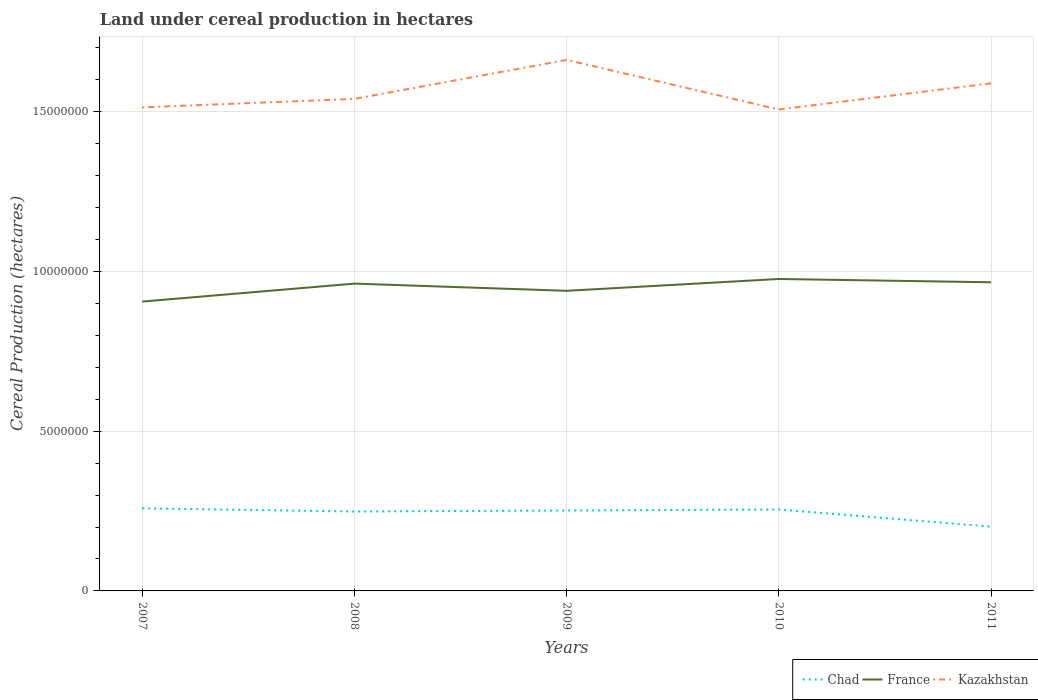Does the line corresponding to Kazakhstan intersect with the line corresponding to Chad?
Make the answer very short. No. Is the number of lines equal to the number of legend labels?
Your response must be concise. Yes. Across all years, what is the maximum land under cereal production in Chad?
Provide a short and direct response. 2.01e+06. What is the total land under cereal production in Chad in the graph?
Give a very brief answer. 9.73e+04. What is the difference between the highest and the second highest land under cereal production in Kazakhstan?
Offer a terse response. 1.55e+06. What is the difference between the highest and the lowest land under cereal production in Chad?
Give a very brief answer. 4. Is the land under cereal production in Kazakhstan strictly greater than the land under cereal production in Chad over the years?
Ensure brevity in your answer.  No. Are the values on the major ticks of Y-axis written in scientific E-notation?
Provide a succinct answer. No. Does the graph contain any zero values?
Give a very brief answer. No. Does the graph contain grids?
Provide a short and direct response. Yes. Where does the legend appear in the graph?
Make the answer very short. Bottom right. What is the title of the graph?
Your answer should be compact. Land under cereal production in hectares. Does "Euro area" appear as one of the legend labels in the graph?
Make the answer very short. No. What is the label or title of the Y-axis?
Your answer should be compact. Cereal Production (hectares). What is the Cereal Production (hectares) in Chad in 2007?
Keep it short and to the point. 2.58e+06. What is the Cereal Production (hectares) in France in 2007?
Offer a terse response. 9.06e+06. What is the Cereal Production (hectares) of Kazakhstan in 2007?
Your answer should be compact. 1.51e+07. What is the Cereal Production (hectares) in Chad in 2008?
Give a very brief answer. 2.49e+06. What is the Cereal Production (hectares) of France in 2008?
Offer a terse response. 9.62e+06. What is the Cereal Production (hectares) of Kazakhstan in 2008?
Provide a succinct answer. 1.54e+07. What is the Cereal Production (hectares) in Chad in 2009?
Your answer should be compact. 2.52e+06. What is the Cereal Production (hectares) in France in 2009?
Your answer should be very brief. 9.39e+06. What is the Cereal Production (hectares) of Kazakhstan in 2009?
Provide a succinct answer. 1.66e+07. What is the Cereal Production (hectares) in Chad in 2010?
Ensure brevity in your answer.  2.55e+06. What is the Cereal Production (hectares) of France in 2010?
Keep it short and to the point. 9.76e+06. What is the Cereal Production (hectares) of Kazakhstan in 2010?
Provide a succinct answer. 1.51e+07. What is the Cereal Production (hectares) of Chad in 2011?
Your response must be concise. 2.01e+06. What is the Cereal Production (hectares) in France in 2011?
Make the answer very short. 9.66e+06. What is the Cereal Production (hectares) of Kazakhstan in 2011?
Ensure brevity in your answer.  1.59e+07. Across all years, what is the maximum Cereal Production (hectares) of Chad?
Offer a very short reply. 2.58e+06. Across all years, what is the maximum Cereal Production (hectares) of France?
Your answer should be very brief. 9.76e+06. Across all years, what is the maximum Cereal Production (hectares) of Kazakhstan?
Your response must be concise. 1.66e+07. Across all years, what is the minimum Cereal Production (hectares) of Chad?
Your answer should be compact. 2.01e+06. Across all years, what is the minimum Cereal Production (hectares) of France?
Your response must be concise. 9.06e+06. Across all years, what is the minimum Cereal Production (hectares) in Kazakhstan?
Offer a very short reply. 1.51e+07. What is the total Cereal Production (hectares) in Chad in the graph?
Your answer should be compact. 1.21e+07. What is the total Cereal Production (hectares) of France in the graph?
Keep it short and to the point. 4.75e+07. What is the total Cereal Production (hectares) in Kazakhstan in the graph?
Provide a succinct answer. 7.81e+07. What is the difference between the Cereal Production (hectares) of Chad in 2007 and that in 2008?
Make the answer very short. 9.73e+04. What is the difference between the Cereal Production (hectares) of France in 2007 and that in 2008?
Offer a terse response. -5.62e+05. What is the difference between the Cereal Production (hectares) in Kazakhstan in 2007 and that in 2008?
Offer a terse response. -2.65e+05. What is the difference between the Cereal Production (hectares) of Chad in 2007 and that in 2009?
Offer a very short reply. 6.77e+04. What is the difference between the Cereal Production (hectares) of France in 2007 and that in 2009?
Make the answer very short. -3.37e+05. What is the difference between the Cereal Production (hectares) in Kazakhstan in 2007 and that in 2009?
Your answer should be very brief. -1.48e+06. What is the difference between the Cereal Production (hectares) in Chad in 2007 and that in 2010?
Offer a very short reply. 3.42e+04. What is the difference between the Cereal Production (hectares) of France in 2007 and that in 2010?
Keep it short and to the point. -7.07e+05. What is the difference between the Cereal Production (hectares) of Kazakhstan in 2007 and that in 2010?
Your answer should be compact. 6.62e+04. What is the difference between the Cereal Production (hectares) in Chad in 2007 and that in 2011?
Give a very brief answer. 5.73e+05. What is the difference between the Cereal Production (hectares) of France in 2007 and that in 2011?
Provide a short and direct response. -6.04e+05. What is the difference between the Cereal Production (hectares) in Kazakhstan in 2007 and that in 2011?
Offer a very short reply. -7.51e+05. What is the difference between the Cereal Production (hectares) of Chad in 2008 and that in 2009?
Your answer should be compact. -2.96e+04. What is the difference between the Cereal Production (hectares) in France in 2008 and that in 2009?
Provide a short and direct response. 2.25e+05. What is the difference between the Cereal Production (hectares) in Kazakhstan in 2008 and that in 2009?
Provide a short and direct response. -1.22e+06. What is the difference between the Cereal Production (hectares) of Chad in 2008 and that in 2010?
Offer a very short reply. -6.31e+04. What is the difference between the Cereal Production (hectares) of France in 2008 and that in 2010?
Ensure brevity in your answer.  -1.45e+05. What is the difference between the Cereal Production (hectares) of Kazakhstan in 2008 and that in 2010?
Make the answer very short. 3.31e+05. What is the difference between the Cereal Production (hectares) in Chad in 2008 and that in 2011?
Ensure brevity in your answer.  4.76e+05. What is the difference between the Cereal Production (hectares) in France in 2008 and that in 2011?
Make the answer very short. -4.14e+04. What is the difference between the Cereal Production (hectares) of Kazakhstan in 2008 and that in 2011?
Keep it short and to the point. -4.87e+05. What is the difference between the Cereal Production (hectares) of Chad in 2009 and that in 2010?
Your answer should be very brief. -3.35e+04. What is the difference between the Cereal Production (hectares) in France in 2009 and that in 2010?
Give a very brief answer. -3.70e+05. What is the difference between the Cereal Production (hectares) in Kazakhstan in 2009 and that in 2010?
Provide a short and direct response. 1.55e+06. What is the difference between the Cereal Production (hectares) in Chad in 2009 and that in 2011?
Your response must be concise. 5.05e+05. What is the difference between the Cereal Production (hectares) in France in 2009 and that in 2011?
Give a very brief answer. -2.67e+05. What is the difference between the Cereal Production (hectares) of Kazakhstan in 2009 and that in 2011?
Give a very brief answer. 7.33e+05. What is the difference between the Cereal Production (hectares) in Chad in 2010 and that in 2011?
Keep it short and to the point. 5.39e+05. What is the difference between the Cereal Production (hectares) of France in 2010 and that in 2011?
Provide a succinct answer. 1.04e+05. What is the difference between the Cereal Production (hectares) of Kazakhstan in 2010 and that in 2011?
Make the answer very short. -8.18e+05. What is the difference between the Cereal Production (hectares) in Chad in 2007 and the Cereal Production (hectares) in France in 2008?
Provide a succinct answer. -7.03e+06. What is the difference between the Cereal Production (hectares) in Chad in 2007 and the Cereal Production (hectares) in Kazakhstan in 2008?
Ensure brevity in your answer.  -1.28e+07. What is the difference between the Cereal Production (hectares) in France in 2007 and the Cereal Production (hectares) in Kazakhstan in 2008?
Give a very brief answer. -6.34e+06. What is the difference between the Cereal Production (hectares) of Chad in 2007 and the Cereal Production (hectares) of France in 2009?
Provide a succinct answer. -6.81e+06. What is the difference between the Cereal Production (hectares) of Chad in 2007 and the Cereal Production (hectares) of Kazakhstan in 2009?
Keep it short and to the point. -1.40e+07. What is the difference between the Cereal Production (hectares) in France in 2007 and the Cereal Production (hectares) in Kazakhstan in 2009?
Offer a very short reply. -7.56e+06. What is the difference between the Cereal Production (hectares) of Chad in 2007 and the Cereal Production (hectares) of France in 2010?
Give a very brief answer. -7.18e+06. What is the difference between the Cereal Production (hectares) in Chad in 2007 and the Cereal Production (hectares) in Kazakhstan in 2010?
Your answer should be very brief. -1.25e+07. What is the difference between the Cereal Production (hectares) of France in 2007 and the Cereal Production (hectares) of Kazakhstan in 2010?
Your answer should be very brief. -6.01e+06. What is the difference between the Cereal Production (hectares) of Chad in 2007 and the Cereal Production (hectares) of France in 2011?
Keep it short and to the point. -7.08e+06. What is the difference between the Cereal Production (hectares) of Chad in 2007 and the Cereal Production (hectares) of Kazakhstan in 2011?
Your response must be concise. -1.33e+07. What is the difference between the Cereal Production (hectares) of France in 2007 and the Cereal Production (hectares) of Kazakhstan in 2011?
Provide a short and direct response. -6.83e+06. What is the difference between the Cereal Production (hectares) of Chad in 2008 and the Cereal Production (hectares) of France in 2009?
Keep it short and to the point. -6.91e+06. What is the difference between the Cereal Production (hectares) of Chad in 2008 and the Cereal Production (hectares) of Kazakhstan in 2009?
Offer a very short reply. -1.41e+07. What is the difference between the Cereal Production (hectares) of France in 2008 and the Cereal Production (hectares) of Kazakhstan in 2009?
Provide a short and direct response. -7.00e+06. What is the difference between the Cereal Production (hectares) of Chad in 2008 and the Cereal Production (hectares) of France in 2010?
Your response must be concise. -7.28e+06. What is the difference between the Cereal Production (hectares) of Chad in 2008 and the Cereal Production (hectares) of Kazakhstan in 2010?
Keep it short and to the point. -1.26e+07. What is the difference between the Cereal Production (hectares) of France in 2008 and the Cereal Production (hectares) of Kazakhstan in 2010?
Keep it short and to the point. -5.45e+06. What is the difference between the Cereal Production (hectares) in Chad in 2008 and the Cereal Production (hectares) in France in 2011?
Offer a very short reply. -7.17e+06. What is the difference between the Cereal Production (hectares) of Chad in 2008 and the Cereal Production (hectares) of Kazakhstan in 2011?
Make the answer very short. -1.34e+07. What is the difference between the Cereal Production (hectares) in France in 2008 and the Cereal Production (hectares) in Kazakhstan in 2011?
Your answer should be compact. -6.27e+06. What is the difference between the Cereal Production (hectares) in Chad in 2009 and the Cereal Production (hectares) in France in 2010?
Ensure brevity in your answer.  -7.25e+06. What is the difference between the Cereal Production (hectares) in Chad in 2009 and the Cereal Production (hectares) in Kazakhstan in 2010?
Offer a very short reply. -1.26e+07. What is the difference between the Cereal Production (hectares) in France in 2009 and the Cereal Production (hectares) in Kazakhstan in 2010?
Give a very brief answer. -5.68e+06. What is the difference between the Cereal Production (hectares) in Chad in 2009 and the Cereal Production (hectares) in France in 2011?
Your answer should be very brief. -7.14e+06. What is the difference between the Cereal Production (hectares) of Chad in 2009 and the Cereal Production (hectares) of Kazakhstan in 2011?
Keep it short and to the point. -1.34e+07. What is the difference between the Cereal Production (hectares) of France in 2009 and the Cereal Production (hectares) of Kazakhstan in 2011?
Give a very brief answer. -6.49e+06. What is the difference between the Cereal Production (hectares) in Chad in 2010 and the Cereal Production (hectares) in France in 2011?
Give a very brief answer. -7.11e+06. What is the difference between the Cereal Production (hectares) of Chad in 2010 and the Cereal Production (hectares) of Kazakhstan in 2011?
Your answer should be compact. -1.33e+07. What is the difference between the Cereal Production (hectares) of France in 2010 and the Cereal Production (hectares) of Kazakhstan in 2011?
Keep it short and to the point. -6.12e+06. What is the average Cereal Production (hectares) of Chad per year?
Keep it short and to the point. 2.43e+06. What is the average Cereal Production (hectares) in France per year?
Offer a very short reply. 9.50e+06. What is the average Cereal Production (hectares) of Kazakhstan per year?
Ensure brevity in your answer.  1.56e+07. In the year 2007, what is the difference between the Cereal Production (hectares) in Chad and Cereal Production (hectares) in France?
Ensure brevity in your answer.  -6.47e+06. In the year 2007, what is the difference between the Cereal Production (hectares) of Chad and Cereal Production (hectares) of Kazakhstan?
Provide a succinct answer. -1.26e+07. In the year 2007, what is the difference between the Cereal Production (hectares) in France and Cereal Production (hectares) in Kazakhstan?
Your response must be concise. -6.08e+06. In the year 2008, what is the difference between the Cereal Production (hectares) in Chad and Cereal Production (hectares) in France?
Your response must be concise. -7.13e+06. In the year 2008, what is the difference between the Cereal Production (hectares) of Chad and Cereal Production (hectares) of Kazakhstan?
Your answer should be compact. -1.29e+07. In the year 2008, what is the difference between the Cereal Production (hectares) of France and Cereal Production (hectares) of Kazakhstan?
Keep it short and to the point. -5.78e+06. In the year 2009, what is the difference between the Cereal Production (hectares) in Chad and Cereal Production (hectares) in France?
Your answer should be compact. -6.88e+06. In the year 2009, what is the difference between the Cereal Production (hectares) in Chad and Cereal Production (hectares) in Kazakhstan?
Provide a short and direct response. -1.41e+07. In the year 2009, what is the difference between the Cereal Production (hectares) of France and Cereal Production (hectares) of Kazakhstan?
Your answer should be very brief. -7.23e+06. In the year 2010, what is the difference between the Cereal Production (hectares) in Chad and Cereal Production (hectares) in France?
Your answer should be very brief. -7.21e+06. In the year 2010, what is the difference between the Cereal Production (hectares) of Chad and Cereal Production (hectares) of Kazakhstan?
Ensure brevity in your answer.  -1.25e+07. In the year 2010, what is the difference between the Cereal Production (hectares) of France and Cereal Production (hectares) of Kazakhstan?
Your response must be concise. -5.31e+06. In the year 2011, what is the difference between the Cereal Production (hectares) of Chad and Cereal Production (hectares) of France?
Keep it short and to the point. -7.65e+06. In the year 2011, what is the difference between the Cereal Production (hectares) of Chad and Cereal Production (hectares) of Kazakhstan?
Offer a terse response. -1.39e+07. In the year 2011, what is the difference between the Cereal Production (hectares) of France and Cereal Production (hectares) of Kazakhstan?
Provide a short and direct response. -6.23e+06. What is the ratio of the Cereal Production (hectares) of Chad in 2007 to that in 2008?
Provide a short and direct response. 1.04. What is the ratio of the Cereal Production (hectares) in France in 2007 to that in 2008?
Keep it short and to the point. 0.94. What is the ratio of the Cereal Production (hectares) of Kazakhstan in 2007 to that in 2008?
Ensure brevity in your answer.  0.98. What is the ratio of the Cereal Production (hectares) of Chad in 2007 to that in 2009?
Make the answer very short. 1.03. What is the ratio of the Cereal Production (hectares) of France in 2007 to that in 2009?
Provide a succinct answer. 0.96. What is the ratio of the Cereal Production (hectares) of Kazakhstan in 2007 to that in 2009?
Offer a terse response. 0.91. What is the ratio of the Cereal Production (hectares) in Chad in 2007 to that in 2010?
Offer a very short reply. 1.01. What is the ratio of the Cereal Production (hectares) in France in 2007 to that in 2010?
Give a very brief answer. 0.93. What is the ratio of the Cereal Production (hectares) in Chad in 2007 to that in 2011?
Give a very brief answer. 1.28. What is the ratio of the Cereal Production (hectares) in France in 2007 to that in 2011?
Your answer should be very brief. 0.94. What is the ratio of the Cereal Production (hectares) in Kazakhstan in 2007 to that in 2011?
Provide a succinct answer. 0.95. What is the ratio of the Cereal Production (hectares) of Chad in 2008 to that in 2009?
Provide a short and direct response. 0.99. What is the ratio of the Cereal Production (hectares) in France in 2008 to that in 2009?
Your answer should be compact. 1.02. What is the ratio of the Cereal Production (hectares) of Kazakhstan in 2008 to that in 2009?
Offer a very short reply. 0.93. What is the ratio of the Cereal Production (hectares) of Chad in 2008 to that in 2010?
Offer a terse response. 0.98. What is the ratio of the Cereal Production (hectares) in France in 2008 to that in 2010?
Ensure brevity in your answer.  0.99. What is the ratio of the Cereal Production (hectares) of Chad in 2008 to that in 2011?
Offer a terse response. 1.24. What is the ratio of the Cereal Production (hectares) of Kazakhstan in 2008 to that in 2011?
Offer a very short reply. 0.97. What is the ratio of the Cereal Production (hectares) of Chad in 2009 to that in 2010?
Your answer should be compact. 0.99. What is the ratio of the Cereal Production (hectares) in France in 2009 to that in 2010?
Your answer should be compact. 0.96. What is the ratio of the Cereal Production (hectares) in Kazakhstan in 2009 to that in 2010?
Your answer should be compact. 1.1. What is the ratio of the Cereal Production (hectares) of Chad in 2009 to that in 2011?
Keep it short and to the point. 1.25. What is the ratio of the Cereal Production (hectares) of France in 2009 to that in 2011?
Offer a terse response. 0.97. What is the ratio of the Cereal Production (hectares) in Kazakhstan in 2009 to that in 2011?
Your response must be concise. 1.05. What is the ratio of the Cereal Production (hectares) of Chad in 2010 to that in 2011?
Provide a short and direct response. 1.27. What is the ratio of the Cereal Production (hectares) in France in 2010 to that in 2011?
Your answer should be compact. 1.01. What is the ratio of the Cereal Production (hectares) in Kazakhstan in 2010 to that in 2011?
Offer a very short reply. 0.95. What is the difference between the highest and the second highest Cereal Production (hectares) in Chad?
Offer a very short reply. 3.42e+04. What is the difference between the highest and the second highest Cereal Production (hectares) of France?
Keep it short and to the point. 1.04e+05. What is the difference between the highest and the second highest Cereal Production (hectares) in Kazakhstan?
Your answer should be compact. 7.33e+05. What is the difference between the highest and the lowest Cereal Production (hectares) in Chad?
Provide a short and direct response. 5.73e+05. What is the difference between the highest and the lowest Cereal Production (hectares) in France?
Offer a terse response. 7.07e+05. What is the difference between the highest and the lowest Cereal Production (hectares) of Kazakhstan?
Provide a short and direct response. 1.55e+06. 